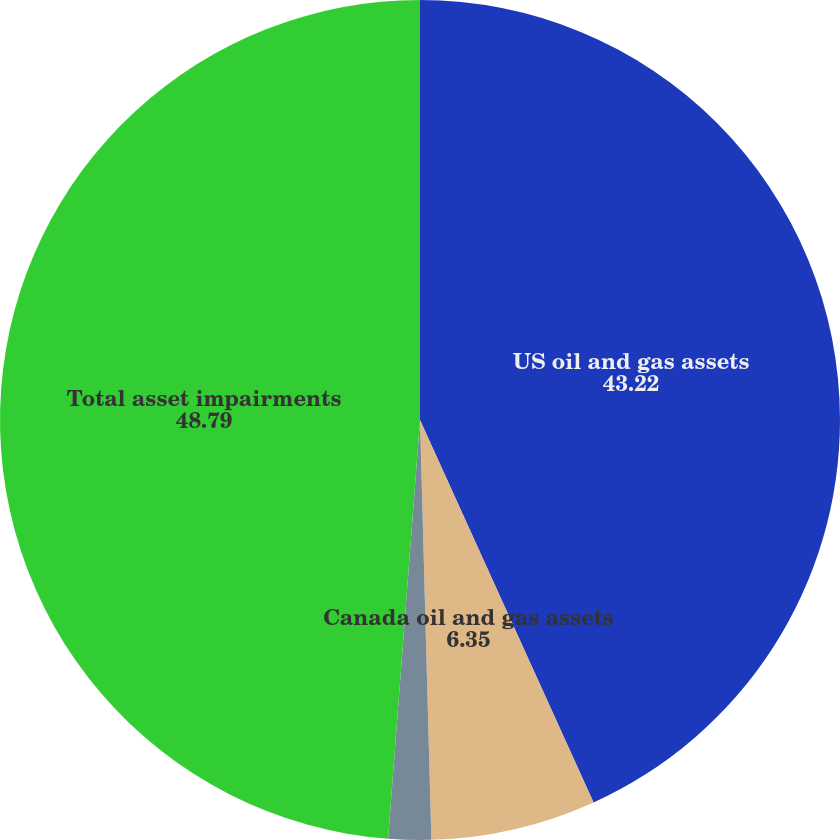<chart> <loc_0><loc_0><loc_500><loc_500><pie_chart><fcel>US oil and gas assets<fcel>Canada oil and gas assets<fcel>Midstream assets<fcel>Total asset impairments<nl><fcel>43.22%<fcel>6.35%<fcel>1.64%<fcel>48.79%<nl></chart> 